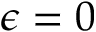Convert formula to latex. <formula><loc_0><loc_0><loc_500><loc_500>\epsilon = 0</formula> 